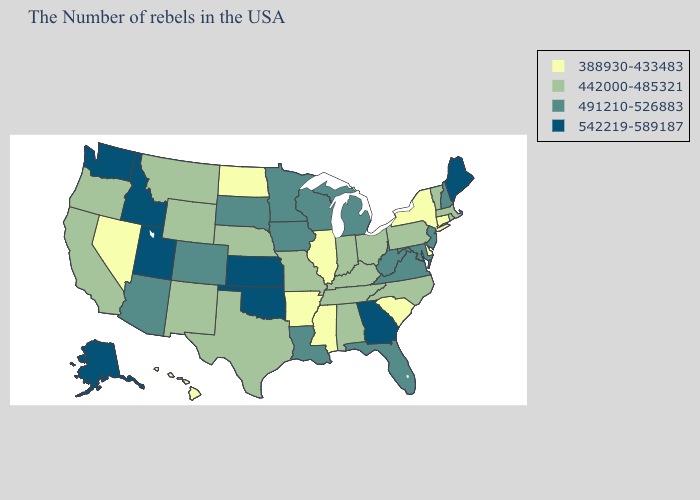What is the value of Kentucky?
Be succinct. 442000-485321. Name the states that have a value in the range 388930-433483?
Give a very brief answer. Connecticut, New York, Delaware, South Carolina, Illinois, Mississippi, Arkansas, North Dakota, Nevada, Hawaii. Name the states that have a value in the range 442000-485321?
Concise answer only. Massachusetts, Rhode Island, Vermont, Pennsylvania, North Carolina, Ohio, Kentucky, Indiana, Alabama, Tennessee, Missouri, Nebraska, Texas, Wyoming, New Mexico, Montana, California, Oregon. Does South Carolina have the lowest value in the USA?
Write a very short answer. Yes. Name the states that have a value in the range 542219-589187?
Answer briefly. Maine, Georgia, Kansas, Oklahoma, Utah, Idaho, Washington, Alaska. Does Nevada have the same value as Ohio?
Be succinct. No. Name the states that have a value in the range 491210-526883?
Be succinct. New Hampshire, New Jersey, Maryland, Virginia, West Virginia, Florida, Michigan, Wisconsin, Louisiana, Minnesota, Iowa, South Dakota, Colorado, Arizona. How many symbols are there in the legend?
Short answer required. 4. What is the value of Maryland?
Write a very short answer. 491210-526883. What is the highest value in the MidWest ?
Short answer required. 542219-589187. Does California have the same value as Florida?
Quick response, please. No. Does Nevada have the lowest value in the USA?
Give a very brief answer. Yes. Is the legend a continuous bar?
Write a very short answer. No. What is the highest value in states that border West Virginia?
Be succinct. 491210-526883. Which states have the lowest value in the Northeast?
Answer briefly. Connecticut, New York. 